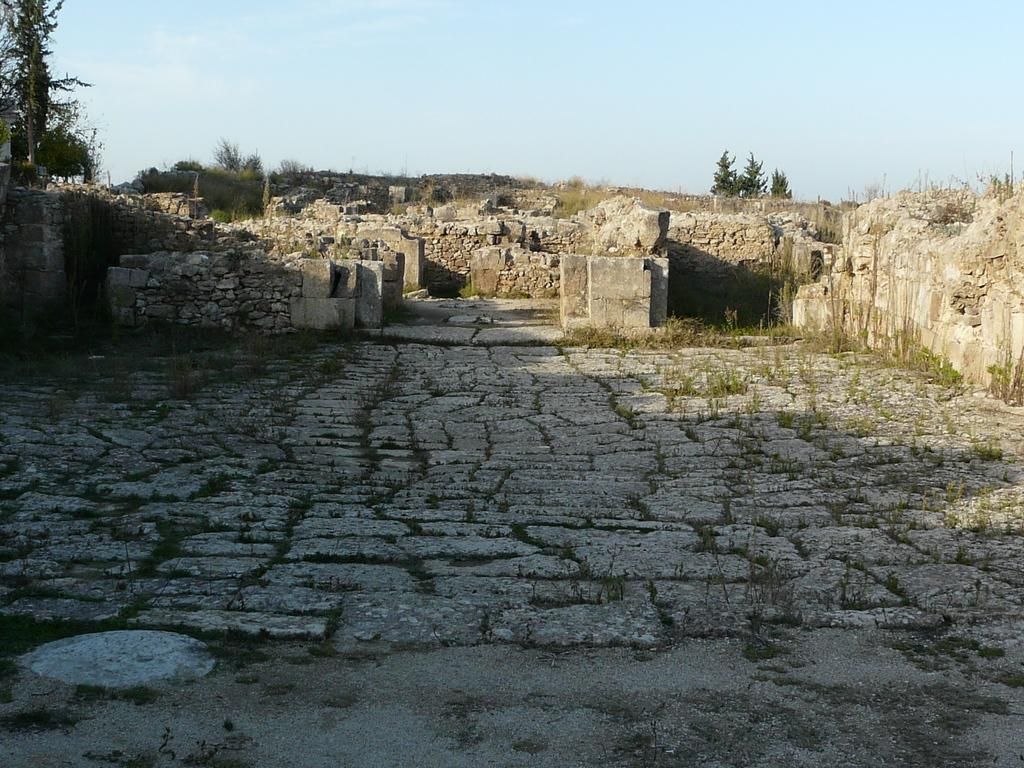What type of surface is visible in the image? The image contains cobblestones. What type of vegetation can be seen in the image? There are trees in the image. What level of education is being taught in the image? There is no school or educational setting present in the image, so it is not possible to determine the level of education being taught. What type of creature can be seen interacting with the trees in the image? There is no creature present in the image; only the cobblestones and trees are visible. 